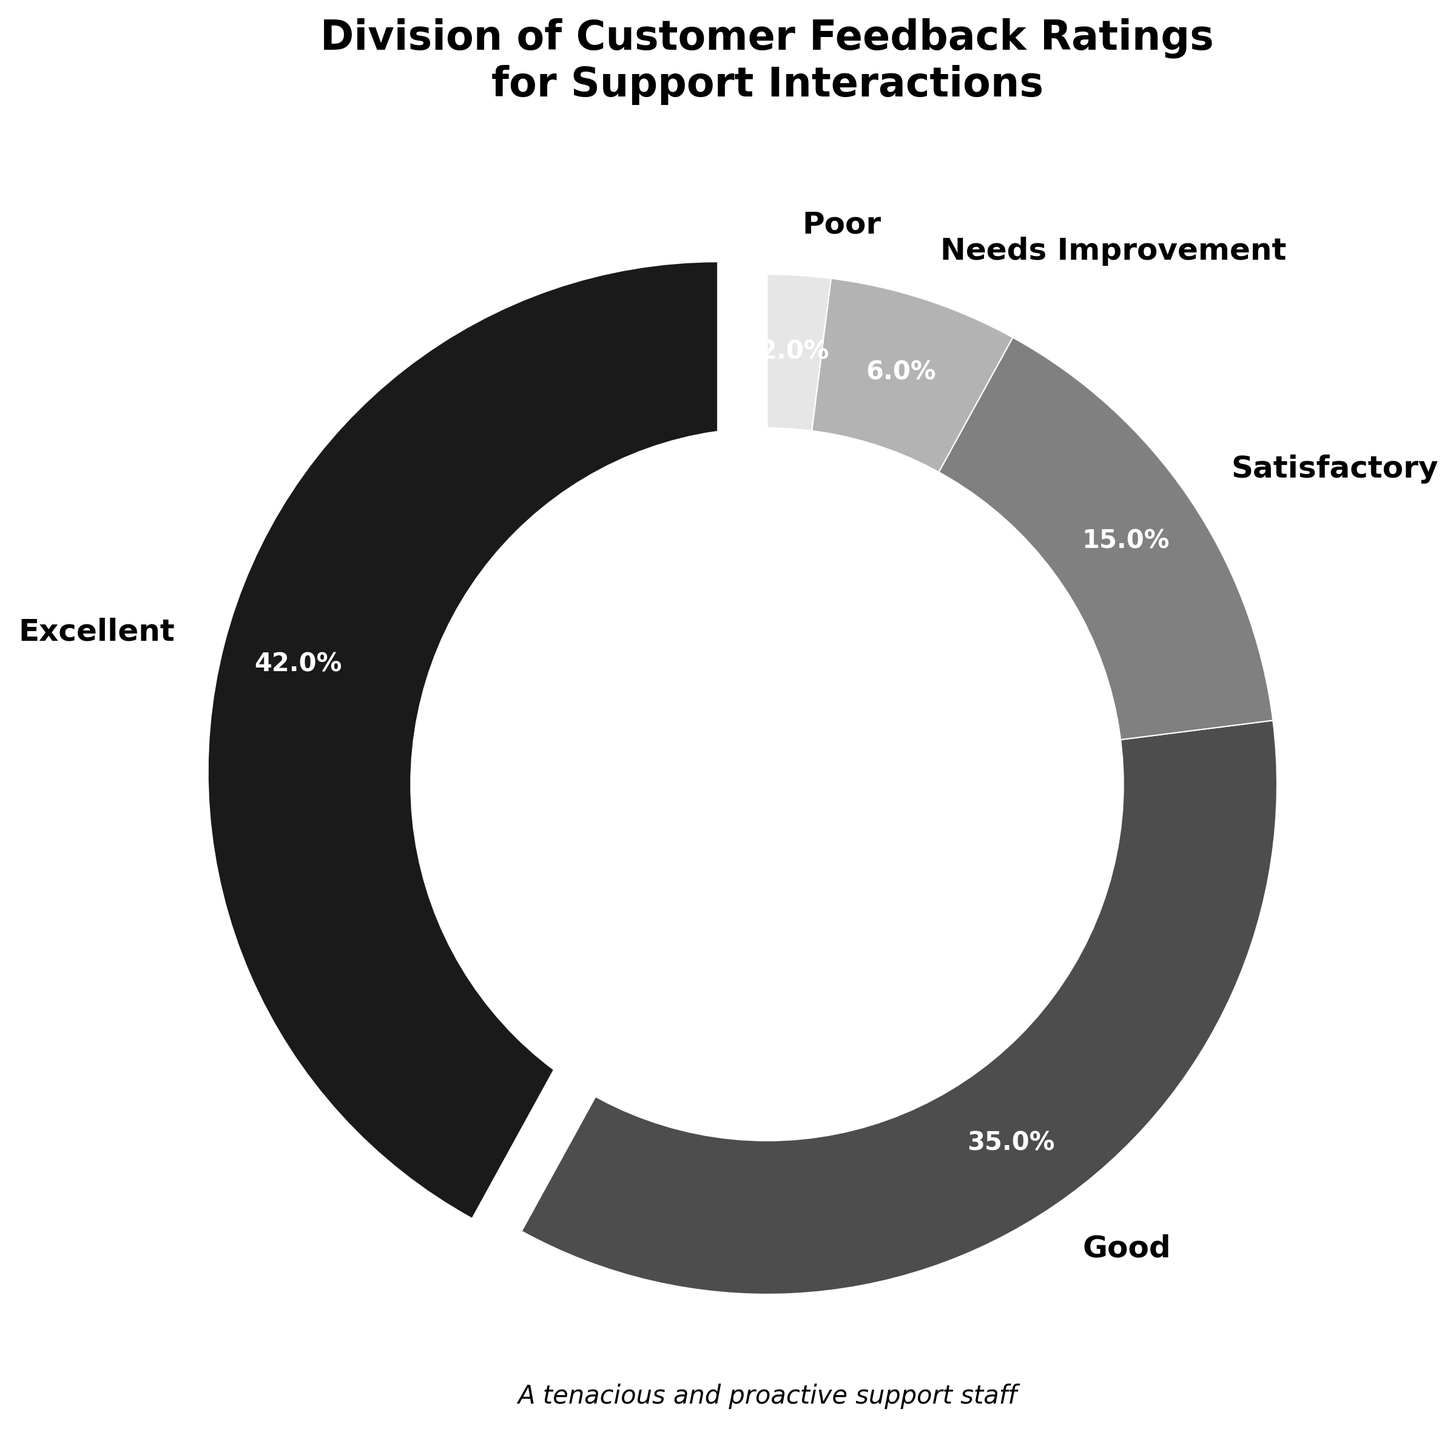What percentage of customers rated the support interactions as Excellent? According to the figure, the 'Excellent' section of the pie chart shows a label indicating its percentage. Simply reading the label tells us that 42% of customers gave an 'Excellent' rating.
Answer: 42% How much higher is the percentage of Good ratings compared to Needs Improvement ratings? From the figure, we can see that 'Good' ratings make up 35%, and 'Needs Improvement' ratings account for 6%. To find the difference, we subtract 6 from 35, giving us 29.
Answer: 29% What is the combined percentage of Satisfactory and Poor ratings? The pie chart shows that 'Satisfactory' ratings account for 15% and 'Poor' ratings make up 2%. Adding these two percentages together yields 17%.
Answer: 17% Which rating is the least common, and what percentage does it hold? By referring to the labels on the pie chart, we can observe that 'Poor' has the smallest slice, indicating it's the least common rating at 2%.
Answer: Poor, 2% If you were to group the ratings into positive (Excellent, Good) and negative (Needs Improvement, Poor), what percentage of the feedback is positive? To answer this, we sum up the percentages for 'Excellent' (42%) and 'Good' (35%) for positive feedback. The total is 42 + 35 = 77%.
Answer: 77% What can you infer about the majority sentiment towards support interactions? The figure shows the 'Excellent' and 'Good' ratings collectively make up a significant majority (42% + 35% = 77%). This suggests that the majority sentiment towards support interactions is positive.
Answer: Positive What visual attribute helps pinpoint the most prominent rating? The figure shows that the 'Excellent' rating slice is separated slightly (exploded) from the pie, making it stand out visually, indicating its prominence.
Answer: Exploded slice How does the size of the Good rating compare to the Satisfactory rating? The 'Good' rating slice appears substantially larger than the 'Satisfactory' slice in the pie chart. Specifically, the 'Good' rating is 35%, while 'Satisfactory' is 15%.
Answer: Larger What's the total percentage represented by the segments that are less than 20% individually? The segments labeled 'Satisfactory' (15%), 'Needs Improvement' (6%), and 'Poor' (2%) are all below 20%. Summing these up gives 15 + 6 + 2 = 23%.
Answer: 23% What feature indicates the title of the pie chart? The title is prominently displayed at the top of the figure, making it clear that it refers to the "Division of Customer Feedback Ratings for Support Interactions."
Answer: Top of the figure 